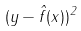<formula> <loc_0><loc_0><loc_500><loc_500>( y - \hat { f } ( x ) ) ^ { 2 }</formula> 